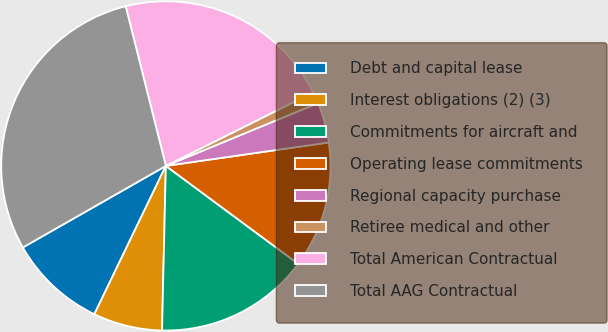Convert chart to OTSL. <chart><loc_0><loc_0><loc_500><loc_500><pie_chart><fcel>Debt and capital lease<fcel>Interest obligations (2) (3)<fcel>Commitments for aircraft and<fcel>Operating lease commitments<fcel>Regional capacity purchase<fcel>Retiree medical and other<fcel>Total American Contractual<fcel>Total AAG Contractual<nl><fcel>9.6%<fcel>6.78%<fcel>15.23%<fcel>12.41%<fcel>3.96%<fcel>1.14%<fcel>21.55%<fcel>29.32%<nl></chart> 